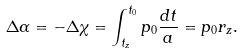Convert formula to latex. <formula><loc_0><loc_0><loc_500><loc_500>\Delta \alpha = - \Delta \chi = \int ^ { t _ { 0 } } _ { t _ { z } } p _ { 0 } \frac { d t } { a } = p _ { 0 } r _ { z } .</formula> 